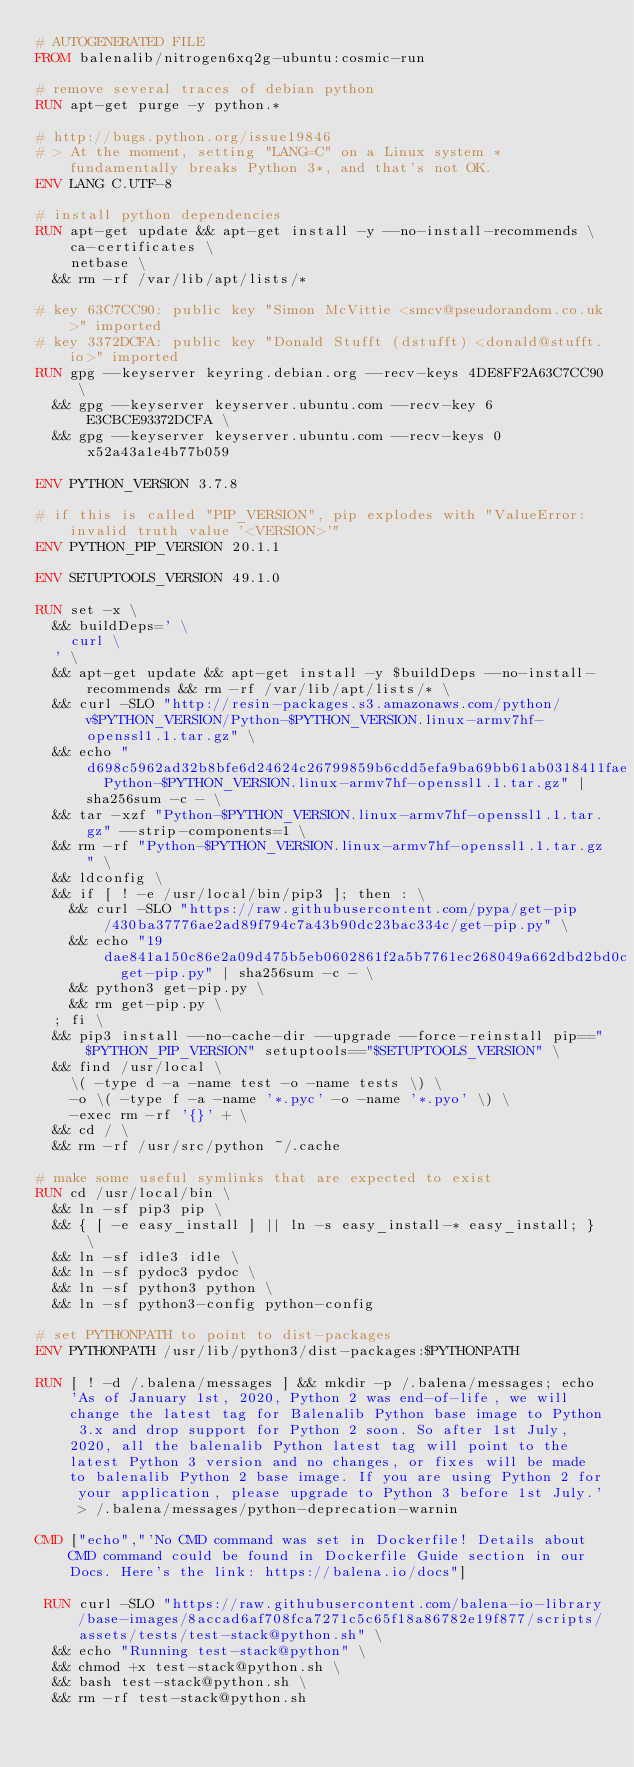Convert code to text. <code><loc_0><loc_0><loc_500><loc_500><_Dockerfile_># AUTOGENERATED FILE
FROM balenalib/nitrogen6xq2g-ubuntu:cosmic-run

# remove several traces of debian python
RUN apt-get purge -y python.*

# http://bugs.python.org/issue19846
# > At the moment, setting "LANG=C" on a Linux system *fundamentally breaks Python 3*, and that's not OK.
ENV LANG C.UTF-8

# install python dependencies
RUN apt-get update && apt-get install -y --no-install-recommends \
		ca-certificates \
		netbase \
	&& rm -rf /var/lib/apt/lists/*

# key 63C7CC90: public key "Simon McVittie <smcv@pseudorandom.co.uk>" imported
# key 3372DCFA: public key "Donald Stufft (dstufft) <donald@stufft.io>" imported
RUN gpg --keyserver keyring.debian.org --recv-keys 4DE8FF2A63C7CC90 \
	&& gpg --keyserver keyserver.ubuntu.com --recv-key 6E3CBCE93372DCFA \
	&& gpg --keyserver keyserver.ubuntu.com --recv-keys 0x52a43a1e4b77b059

ENV PYTHON_VERSION 3.7.8

# if this is called "PIP_VERSION", pip explodes with "ValueError: invalid truth value '<VERSION>'"
ENV PYTHON_PIP_VERSION 20.1.1

ENV SETUPTOOLS_VERSION 49.1.0

RUN set -x \
	&& buildDeps=' \
		curl \
	' \
	&& apt-get update && apt-get install -y $buildDeps --no-install-recommends && rm -rf /var/lib/apt/lists/* \
	&& curl -SLO "http://resin-packages.s3.amazonaws.com/python/v$PYTHON_VERSION/Python-$PYTHON_VERSION.linux-armv7hf-openssl1.1.tar.gz" \
	&& echo "d698c5962ad32b8bfe6d24624c26799859b6cdd5efa9ba69bb61ab0318411fae  Python-$PYTHON_VERSION.linux-armv7hf-openssl1.1.tar.gz" | sha256sum -c - \
	&& tar -xzf "Python-$PYTHON_VERSION.linux-armv7hf-openssl1.1.tar.gz" --strip-components=1 \
	&& rm -rf "Python-$PYTHON_VERSION.linux-armv7hf-openssl1.1.tar.gz" \
	&& ldconfig \
	&& if [ ! -e /usr/local/bin/pip3 ]; then : \
		&& curl -SLO "https://raw.githubusercontent.com/pypa/get-pip/430ba37776ae2ad89f794c7a43b90dc23bac334c/get-pip.py" \
		&& echo "19dae841a150c86e2a09d475b5eb0602861f2a5b7761ec268049a662dbd2bd0c  get-pip.py" | sha256sum -c - \
		&& python3 get-pip.py \
		&& rm get-pip.py \
	; fi \
	&& pip3 install --no-cache-dir --upgrade --force-reinstall pip=="$PYTHON_PIP_VERSION" setuptools=="$SETUPTOOLS_VERSION" \
	&& find /usr/local \
		\( -type d -a -name test -o -name tests \) \
		-o \( -type f -a -name '*.pyc' -o -name '*.pyo' \) \
		-exec rm -rf '{}' + \
	&& cd / \
	&& rm -rf /usr/src/python ~/.cache

# make some useful symlinks that are expected to exist
RUN cd /usr/local/bin \
	&& ln -sf pip3 pip \
	&& { [ -e easy_install ] || ln -s easy_install-* easy_install; } \
	&& ln -sf idle3 idle \
	&& ln -sf pydoc3 pydoc \
	&& ln -sf python3 python \
	&& ln -sf python3-config python-config

# set PYTHONPATH to point to dist-packages
ENV PYTHONPATH /usr/lib/python3/dist-packages:$PYTHONPATH

RUN [ ! -d /.balena/messages ] && mkdir -p /.balena/messages; echo 'As of January 1st, 2020, Python 2 was end-of-life, we will change the latest tag for Balenalib Python base image to Python 3.x and drop support for Python 2 soon. So after 1st July, 2020, all the balenalib Python latest tag will point to the latest Python 3 version and no changes, or fixes will be made to balenalib Python 2 base image. If you are using Python 2 for your application, please upgrade to Python 3 before 1st July.' > /.balena/messages/python-deprecation-warnin

CMD ["echo","'No CMD command was set in Dockerfile! Details about CMD command could be found in Dockerfile Guide section in our Docs. Here's the link: https://balena.io/docs"]

 RUN curl -SLO "https://raw.githubusercontent.com/balena-io-library/base-images/8accad6af708fca7271c5c65f18a86782e19f877/scripts/assets/tests/test-stack@python.sh" \
  && echo "Running test-stack@python" \
  && chmod +x test-stack@python.sh \
  && bash test-stack@python.sh \
  && rm -rf test-stack@python.sh 
</code> 